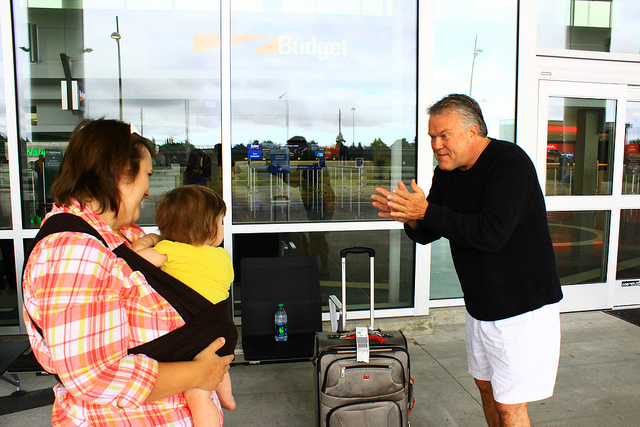Please identify all text content in this image. Budget 